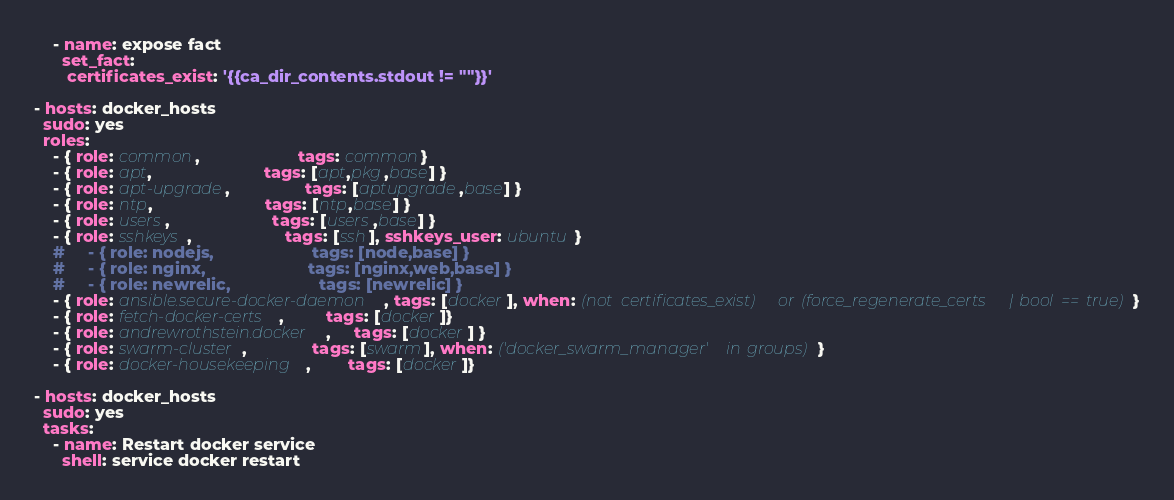Convert code to text. <code><loc_0><loc_0><loc_500><loc_500><_YAML_>
    - name: expose fact
      set_fact:
       certificates_exist: '{{ca_dir_contents.stdout != ""}}'

- hosts: docker_hosts
  sudo: yes
  roles:
    - { role: common,                     tags: common}
    - { role: apt,                        tags: [apt,pkg,base] }
    - { role: apt-upgrade,                tags: [aptupgrade,base] }
    - { role: ntp,                        tags: [ntp,base] }
    - { role: users,                      tags: [users,base] }
    - { role: sshkeys,                    tags: [ssh], sshkeys_user: ubuntu }
    #     - { role: nodejs,                     tags: [node,base] }
    #     - { role: nginx,                      tags: [nginx,web,base] }
    #     - { role: newrelic,                   tags: [newrelic] }
    - { role: ansible.secure-docker-daemon, tags: [docker], when: (not certificates_exist) or (force_regenerate_certs | bool == true) }
    - { role: fetch-docker-certs,         tags: [docker]}
    - { role: andrewrothstein.docker,     tags: [docker] }
    - { role: swarm-cluster,              tags: [swarm], when: ('docker_swarm_manager' in groups) }
    - { role: docker-housekeeping,        tags: [docker]}

- hosts: docker_hosts
  sudo: yes
  tasks:
    - name: Restart docker service
      shell: service docker restart</code> 